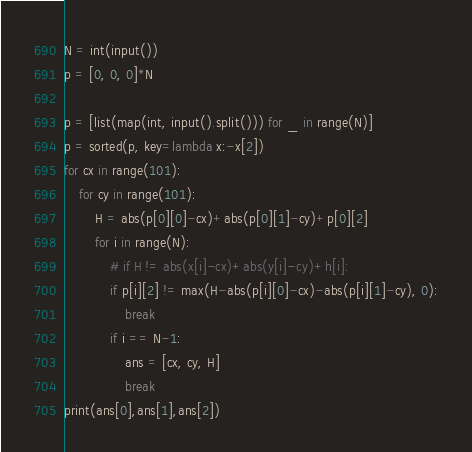<code> <loc_0><loc_0><loc_500><loc_500><_Python_>N = int(input())
p = [0, 0, 0]*N

p = [list(map(int, input().split())) for _ in range(N)]
p = sorted(p, key=lambda x:-x[2])
for cx in range(101):
	for cy in range(101):
		H = abs(p[0][0]-cx)+abs(p[0][1]-cy)+p[0][2]
		for i in range(N):
			# if H != abs(x[i]-cx)+abs(y[i]-cy)+h[i]:
			if p[i][2] != max(H-abs(p[i][0]-cx)-abs(p[i][1]-cy), 0):
				break
			if i == N-1:
				ans = [cx, cy, H]
				break
print(ans[0],ans[1],ans[2])
</code> 